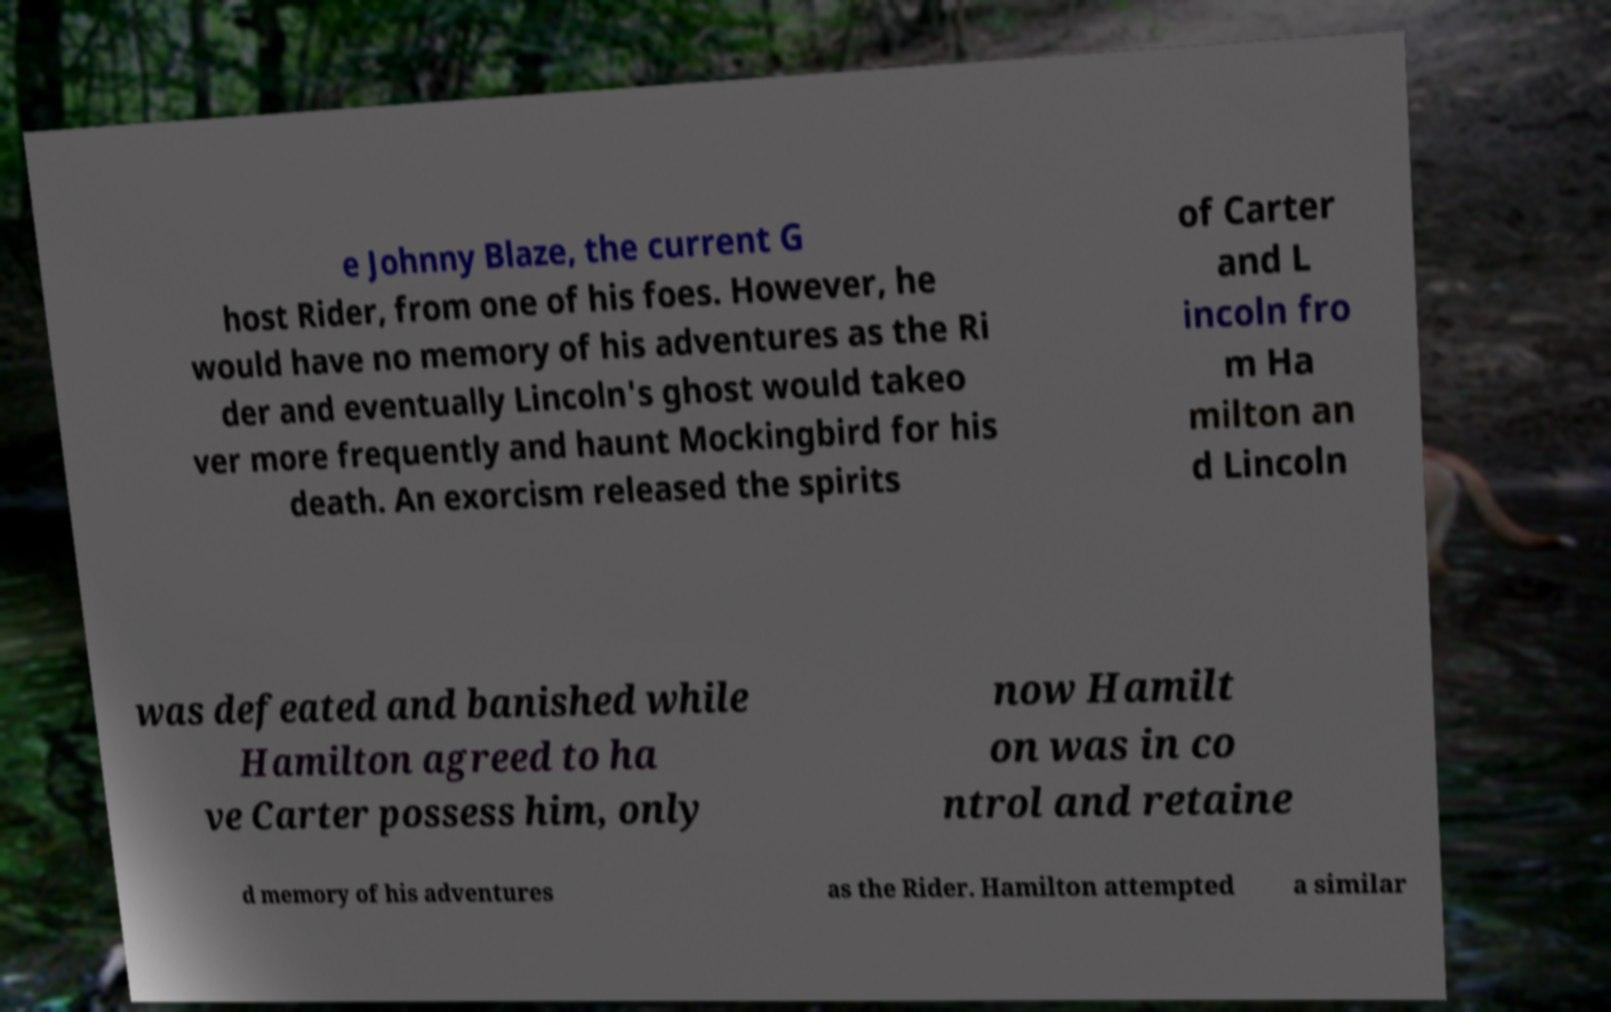Please read and relay the text visible in this image. What does it say? e Johnny Blaze, the current G host Rider, from one of his foes. However, he would have no memory of his adventures as the Ri der and eventually Lincoln's ghost would takeo ver more frequently and haunt Mockingbird for his death. An exorcism released the spirits of Carter and L incoln fro m Ha milton an d Lincoln was defeated and banished while Hamilton agreed to ha ve Carter possess him, only now Hamilt on was in co ntrol and retaine d memory of his adventures as the Rider. Hamilton attempted a similar 